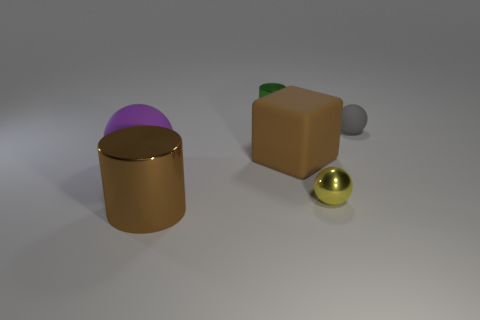There is a small object that is in front of the brown rubber block; how many big brown rubber blocks are left of it?
Offer a very short reply. 1. Are there any other things that have the same color as the big cylinder?
Offer a very short reply. Yes. What number of things are yellow metal objects or things behind the large cylinder?
Provide a succinct answer. 5. There is a tiny ball that is in front of the big brown thing that is behind the metallic cylinder on the left side of the small cylinder; what is its material?
Give a very brief answer. Metal. What is the size of the other gray sphere that is the same material as the large ball?
Provide a short and direct response. Small. There is a big thing on the left side of the shiny object that is to the left of the tiny green thing; what is its color?
Offer a very short reply. Purple. How many small yellow spheres have the same material as the large brown cylinder?
Provide a succinct answer. 1. How many matte things are either red cylinders or small yellow spheres?
Your response must be concise. 0. There is a ball that is the same size as the block; what material is it?
Your response must be concise. Rubber. Is there a big thing made of the same material as the tiny gray object?
Offer a very short reply. Yes. 